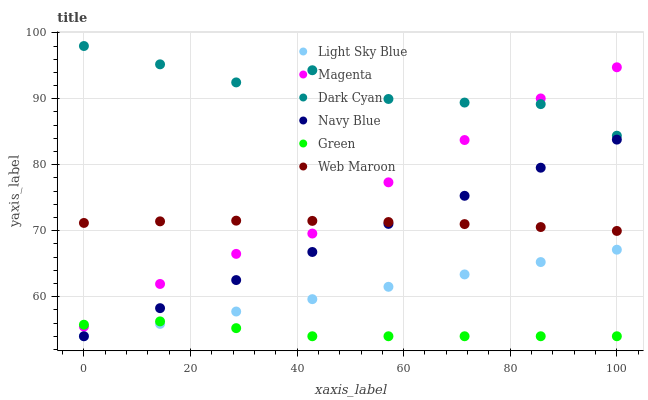Does Green have the minimum area under the curve?
Answer yes or no. Yes. Does Dark Cyan have the maximum area under the curve?
Answer yes or no. Yes. Does Web Maroon have the minimum area under the curve?
Answer yes or no. No. Does Web Maroon have the maximum area under the curve?
Answer yes or no. No. Is Light Sky Blue the smoothest?
Answer yes or no. Yes. Is Dark Cyan the roughest?
Answer yes or no. Yes. Is Web Maroon the smoothest?
Answer yes or no. No. Is Web Maroon the roughest?
Answer yes or no. No. Does Navy Blue have the lowest value?
Answer yes or no. Yes. Does Web Maroon have the lowest value?
Answer yes or no. No. Does Dark Cyan have the highest value?
Answer yes or no. Yes. Does Web Maroon have the highest value?
Answer yes or no. No. Is Navy Blue less than Dark Cyan?
Answer yes or no. Yes. Is Dark Cyan greater than Navy Blue?
Answer yes or no. Yes. Does Web Maroon intersect Navy Blue?
Answer yes or no. Yes. Is Web Maroon less than Navy Blue?
Answer yes or no. No. Is Web Maroon greater than Navy Blue?
Answer yes or no. No. Does Navy Blue intersect Dark Cyan?
Answer yes or no. No. 